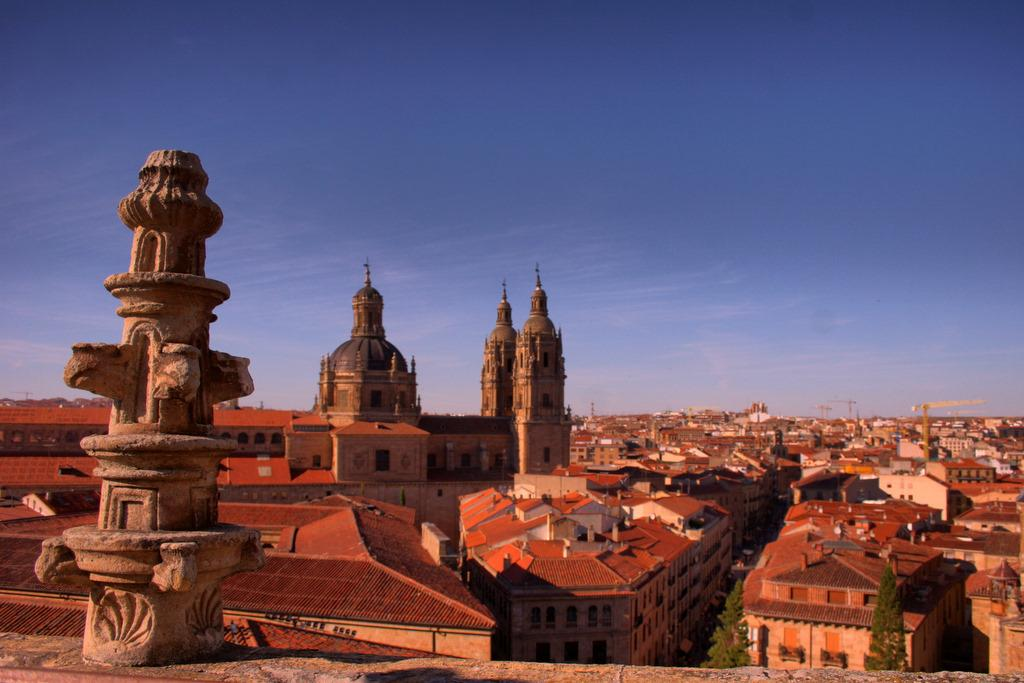What structure is located on the left side of the image? There is a tower on a platform on the left side of the image. What can be seen in the background of the image? In the background of the image, there are buildings, houses, windows, trees, poles, roofs, cranes, and clouds in the sky. What degree of loss can be observed in the image? There is no indication of loss in the image; it features a tower on a platform and various elements in the background. What type of circle is present in the image? There is no circle present in the image. 